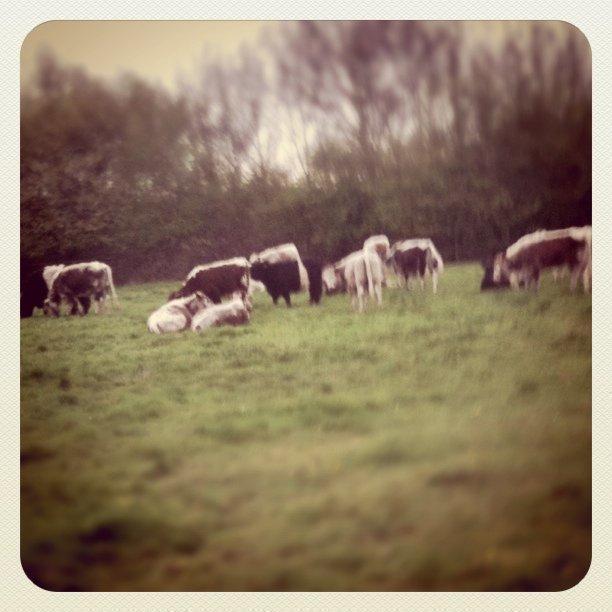What is wrong with this image?
Pick the right solution, then justify: 'Answer: answer
Rationale: rationale.'
Options: Blurry, too close, too far, broken. Answer: blurry.
Rationale: The image is blurry. 